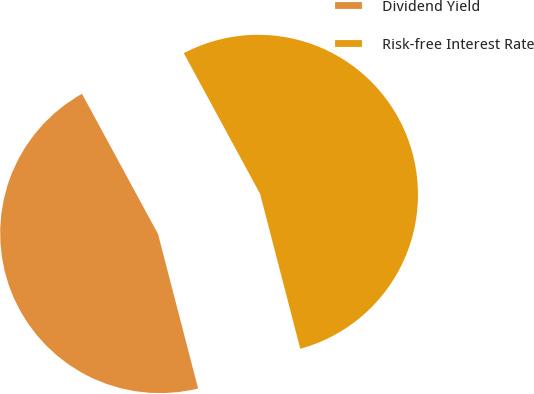Convert chart to OTSL. <chart><loc_0><loc_0><loc_500><loc_500><pie_chart><fcel>Dividend Yield<fcel>Risk-free Interest Rate<nl><fcel>46.13%<fcel>53.87%<nl></chart> 